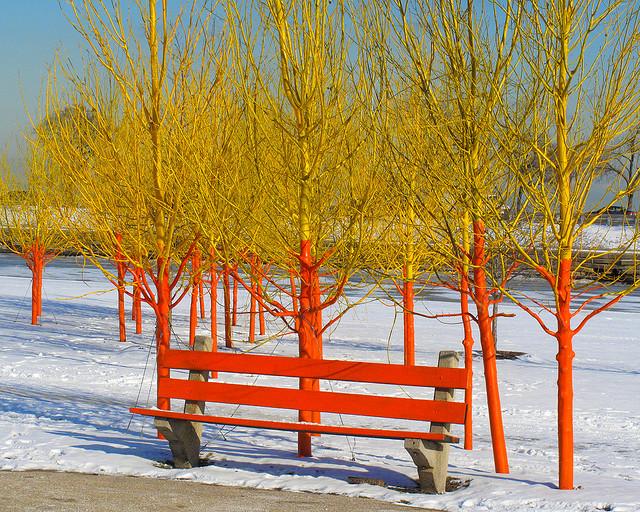What is the purpose of this display?
Answer briefly. Art. Has it snowed recently?
Write a very short answer. Yes. Are the trees naturally this color?
Keep it brief. No. 